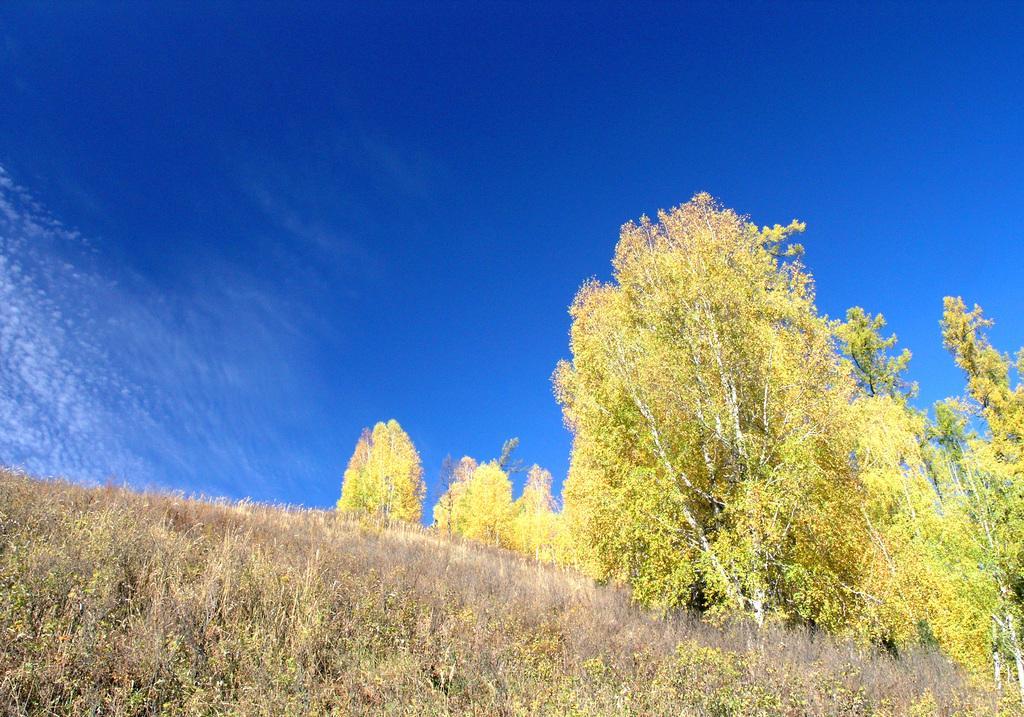Describe this image in one or two sentences. In this picture we can see trees and in the background we can see the sky. 